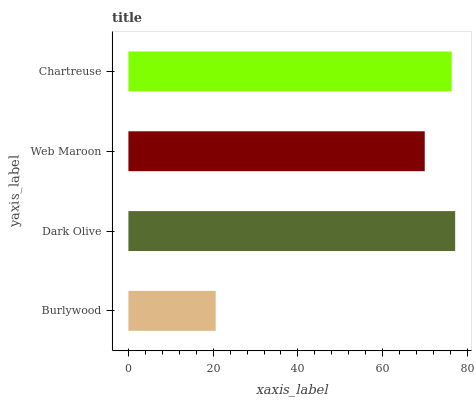Is Burlywood the minimum?
Answer yes or no. Yes. Is Dark Olive the maximum?
Answer yes or no. Yes. Is Web Maroon the minimum?
Answer yes or no. No. Is Web Maroon the maximum?
Answer yes or no. No. Is Dark Olive greater than Web Maroon?
Answer yes or no. Yes. Is Web Maroon less than Dark Olive?
Answer yes or no. Yes. Is Web Maroon greater than Dark Olive?
Answer yes or no. No. Is Dark Olive less than Web Maroon?
Answer yes or no. No. Is Chartreuse the high median?
Answer yes or no. Yes. Is Web Maroon the low median?
Answer yes or no. Yes. Is Web Maroon the high median?
Answer yes or no. No. Is Chartreuse the low median?
Answer yes or no. No. 